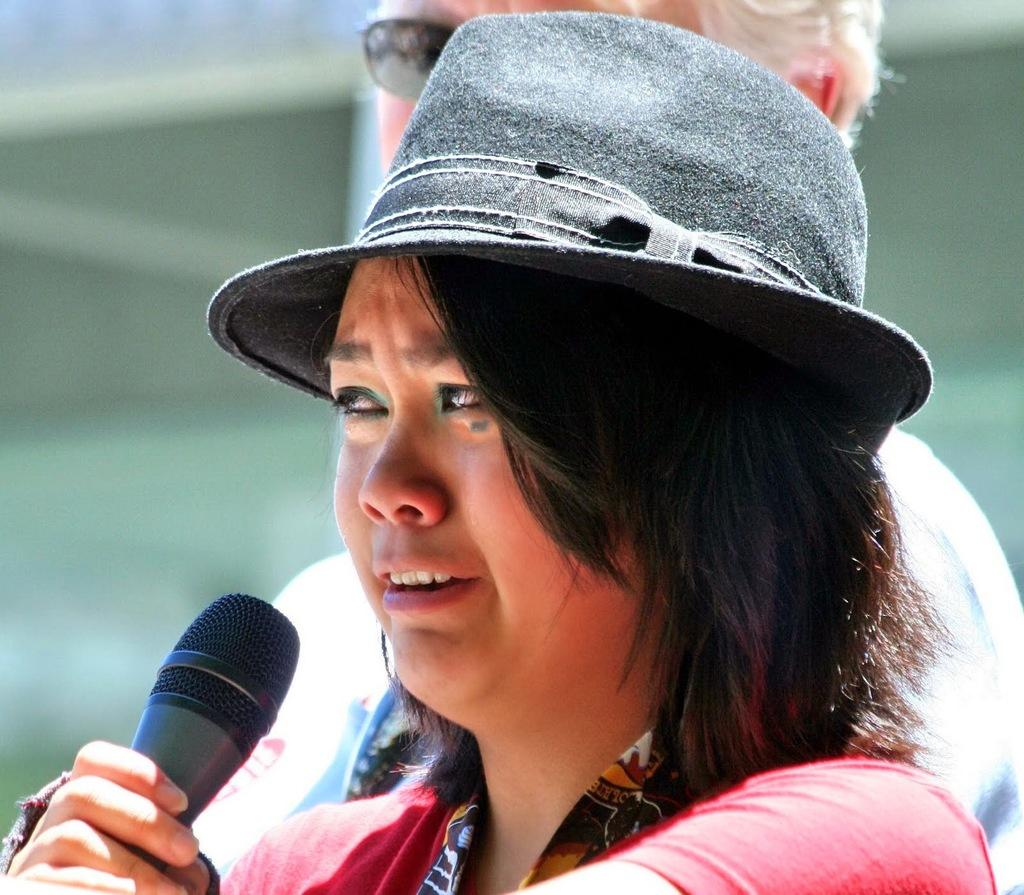Who is the main subject in the image? There is a woman in the image. What is the woman wearing on her head? The woman is wearing a hat. What object is the woman holding in her hand? The woman is holding a microphone. Can you describe the other person visible in the image? There is another person in the background of the image. What type of banana is the woman holding in the image? There is no banana present in the image; the woman is holding a microphone. Can you tell me how many dolls are visible in the image? There are no dolls present in the image. 